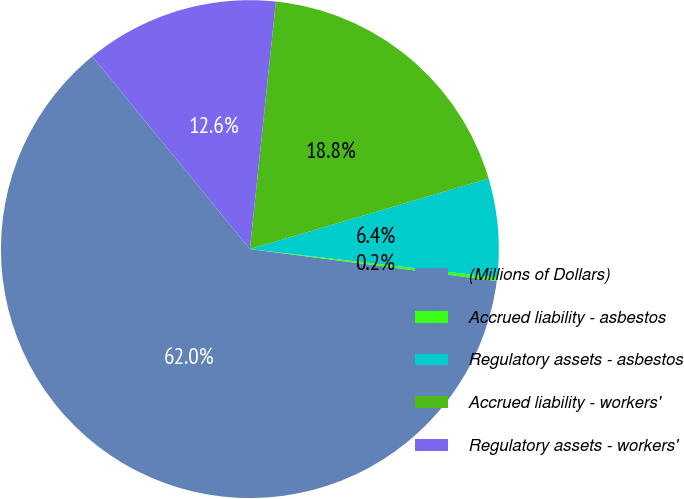Convert chart. <chart><loc_0><loc_0><loc_500><loc_500><pie_chart><fcel>(Millions of Dollars)<fcel>Accrued liability - asbestos<fcel>Regulatory assets - asbestos<fcel>Accrued liability - workers'<fcel>Regulatory assets - workers'<nl><fcel>62.04%<fcel>0.22%<fcel>6.4%<fcel>18.76%<fcel>12.58%<nl></chart> 